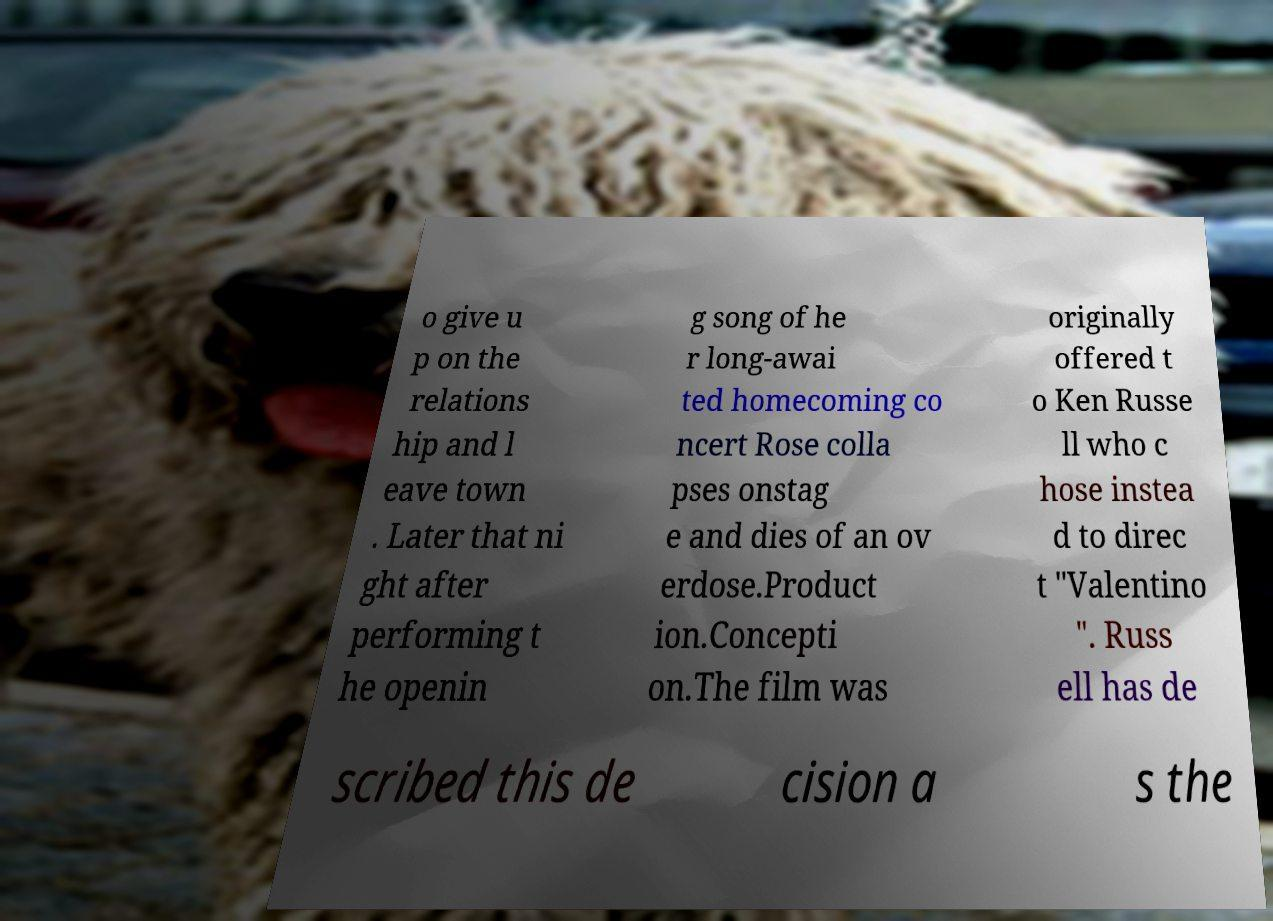Could you extract and type out the text from this image? o give u p on the relations hip and l eave town . Later that ni ght after performing t he openin g song of he r long-awai ted homecoming co ncert Rose colla pses onstag e and dies of an ov erdose.Product ion.Concepti on.The film was originally offered t o Ken Russe ll who c hose instea d to direc t "Valentino ". Russ ell has de scribed this de cision a s the 